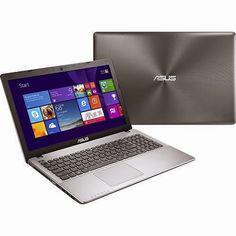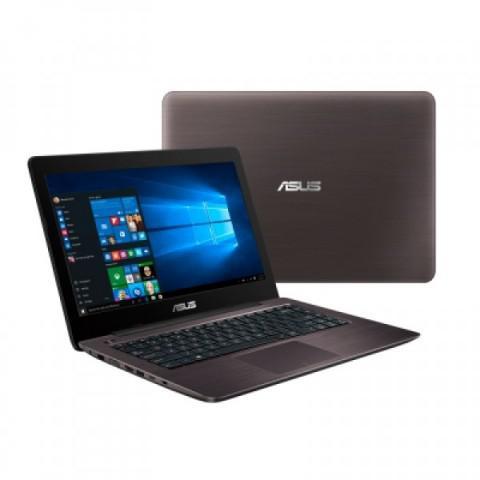The first image is the image on the left, the second image is the image on the right. For the images shown, is this caption "The left image features an open, rightward facing laptop overlapping an upright closed silver laptop, and the right image contains only an open, rightward facing laptop." true? Answer yes or no. No. The first image is the image on the left, the second image is the image on the right. For the images shown, is this caption "One image contains only one laptop and the other image contains one open laptop and one closed laptop." true? Answer yes or no. No. 